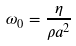Convert formula to latex. <formula><loc_0><loc_0><loc_500><loc_500>\omega _ { 0 } = \frac { \eta } { \rho a ^ { 2 } }</formula> 